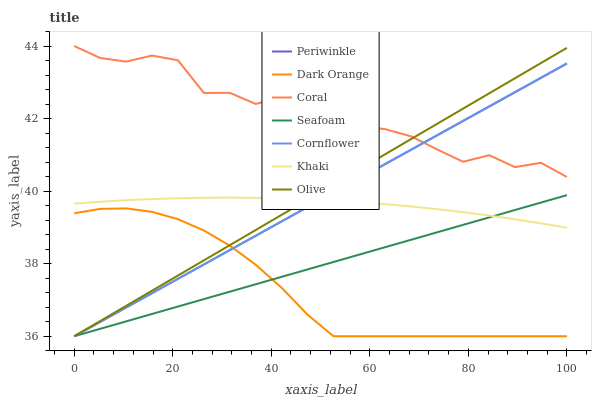Does Dark Orange have the minimum area under the curve?
Answer yes or no. Yes. Does Coral have the maximum area under the curve?
Answer yes or no. Yes. Does Khaki have the minimum area under the curve?
Answer yes or no. No. Does Khaki have the maximum area under the curve?
Answer yes or no. No. Is Seafoam the smoothest?
Answer yes or no. Yes. Is Coral the roughest?
Answer yes or no. Yes. Is Khaki the smoothest?
Answer yes or no. No. Is Khaki the roughest?
Answer yes or no. No. Does Dark Orange have the lowest value?
Answer yes or no. Yes. Does Khaki have the lowest value?
Answer yes or no. No. Does Coral have the highest value?
Answer yes or no. Yes. Does Khaki have the highest value?
Answer yes or no. No. Is Dark Orange less than Coral?
Answer yes or no. Yes. Is Coral greater than Seafoam?
Answer yes or no. Yes. Does Seafoam intersect Khaki?
Answer yes or no. Yes. Is Seafoam less than Khaki?
Answer yes or no. No. Is Seafoam greater than Khaki?
Answer yes or no. No. Does Dark Orange intersect Coral?
Answer yes or no. No. 